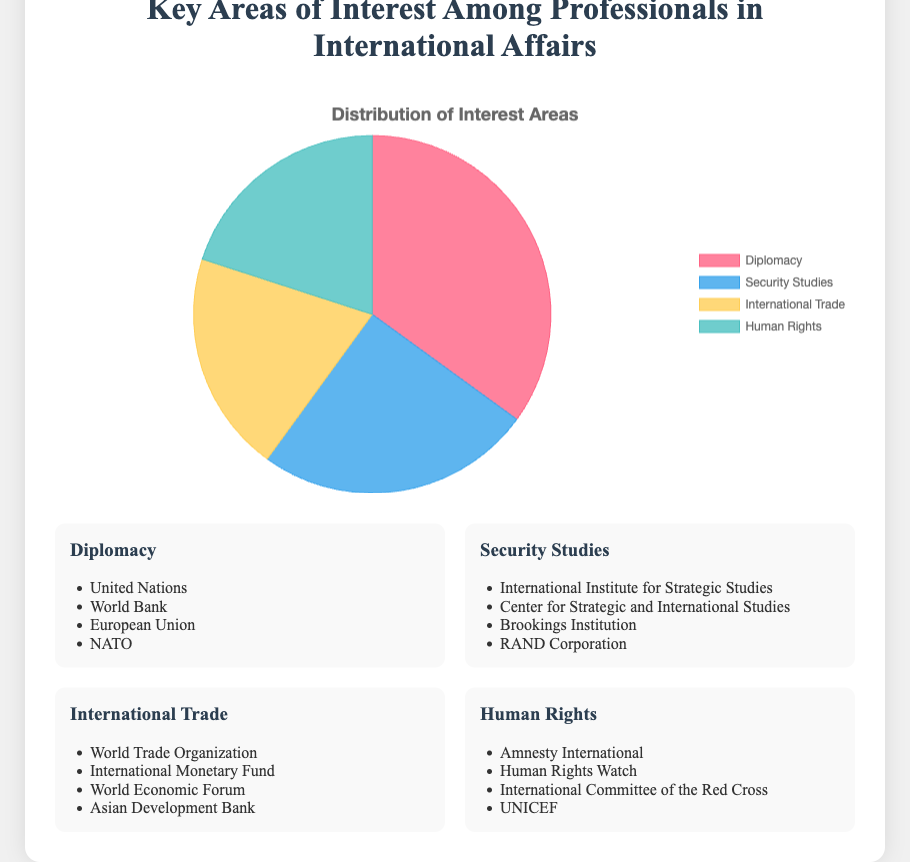Which key area of interest has the highest percentage? The figure shows that Diplomacy has a 35% share, higher than any other interest area.
Answer: Diplomacy Which two key areas of interest have equal percentages? The figure indicates that International Trade and Human Rights both have a percentage of 20%.
Answer: International Trade and Human Rights What is the combined percentage of Security Studies and Human Rights? According to the figure, Security Studies have a 25% share, and Human Rights have a 20% share. Adding these together yields 25% + 20% = 45%.
Answer: 45% How much more percentage does Diplomacy have compared to International Trade? Diplomacy has 35% while International Trade has 20%. The difference between them is 35% - 20% = 15%.
Answer: 15% What fraction of the total interest is represented by International Trade? International Trade makes up 20% of the total. In fraction terms, this is 20/100 or simplified to 1/5.
Answer: 1/5 Which key area of interest is represented by the red color in the pie chart? The red color in the pie chart corresponds to Diplomacy.
Answer: Diplomacy What is the average percentage of the four key areas of interest? Adding the percentages for Diplomacy, Security Studies, International Trade, and Human Rights (35% + 25% + 20% + 20%) equals 100%. Dividing by 4 gives an average of 100% / 4 = 25%.
Answer: 25% Which key area of interest has the smallest percentage, and what is its associated color? Both International Trade and Human Rights have the smallest percentage at 20%. In the pie chart, International Trade is blue, and Human Rights is green.
Answer: International Trade (blue) and Human Rights (green) Which area has a percentage closest to one-third of the total interest? One-third of 100% is approximately 33.33%. Diplomacy has the closest percentage at 35%.
Answer: Diplomacy 